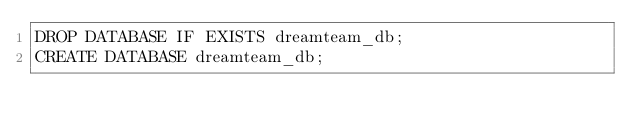Convert code to text. <code><loc_0><loc_0><loc_500><loc_500><_SQL_>DROP DATABASE IF EXISTS dreamteam_db;
CREATE DATABASE dreamteam_db;
</code> 